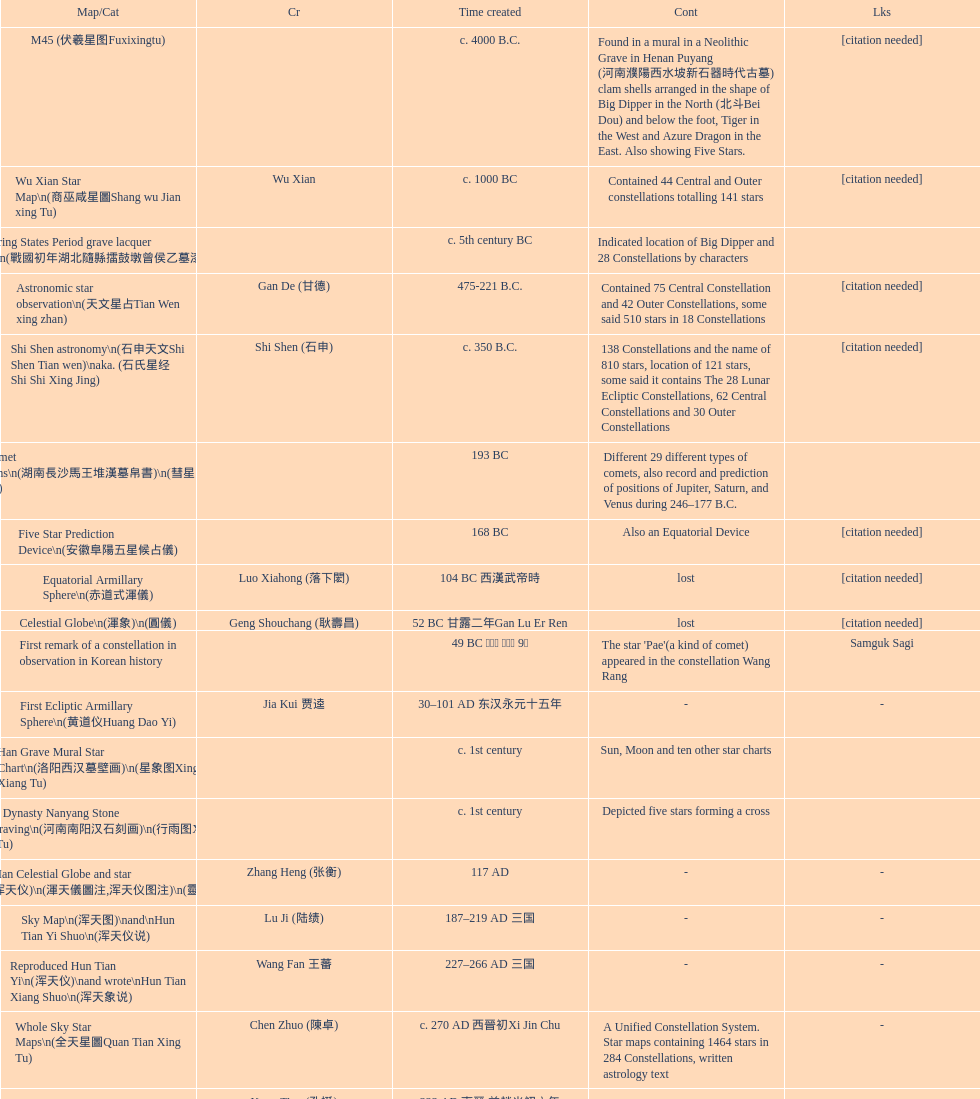Identify three objects invented shortly after the equatorial armillary sphere. Celestial Globe (渾象) (圓儀), First remark of a constellation in observation in Korean history, First Ecliptic Armillary Sphere (黄道仪Huang Dao Yi). 